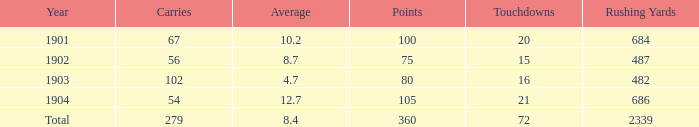What is the sum of carries associated with 80 points and fewer than 16 touchdowns? None. 